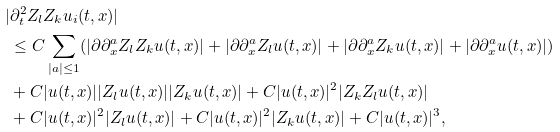<formula> <loc_0><loc_0><loc_500><loc_500>| & \partial _ { t } ^ { 2 } Z _ { l } Z _ { k } u _ { i } ( t , x ) | \\ & \leq C \sum _ { | a | \leq 1 } ( | \partial \partial _ { x } ^ { a } Z _ { l } Z _ { k } u ( t , x ) | + | \partial \partial _ { x } ^ { a } Z _ { l } u ( t , x ) | + | \partial \partial _ { x } ^ { a } Z _ { k } u ( t , x ) | + | \partial \partial _ { x } ^ { a } u ( t , x ) | ) \\ & + C | u ( t , x ) | | Z _ { l } u ( t , x ) | | Z _ { k } u ( t , x ) | + C | u ( t , x ) | ^ { 2 } | Z _ { k } Z _ { l } u ( t , x ) | \\ & + C | u ( t , x ) | ^ { 2 } | Z _ { l } u ( t , x ) | + C | u ( t , x ) | ^ { 2 } | Z _ { k } u ( t , x ) | + C | u ( t , x ) | ^ { 3 } ,</formula> 